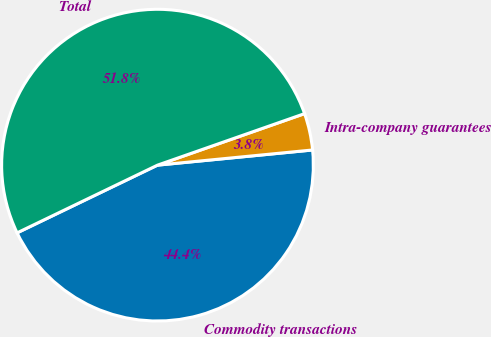Convert chart to OTSL. <chart><loc_0><loc_0><loc_500><loc_500><pie_chart><fcel>Commodity transactions<fcel>Intra-company guarantees<fcel>Total<nl><fcel>44.4%<fcel>3.81%<fcel>51.79%<nl></chart> 